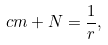<formula> <loc_0><loc_0><loc_500><loc_500>c m + N = \frac { 1 } { r } ,</formula> 